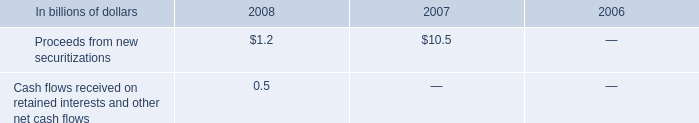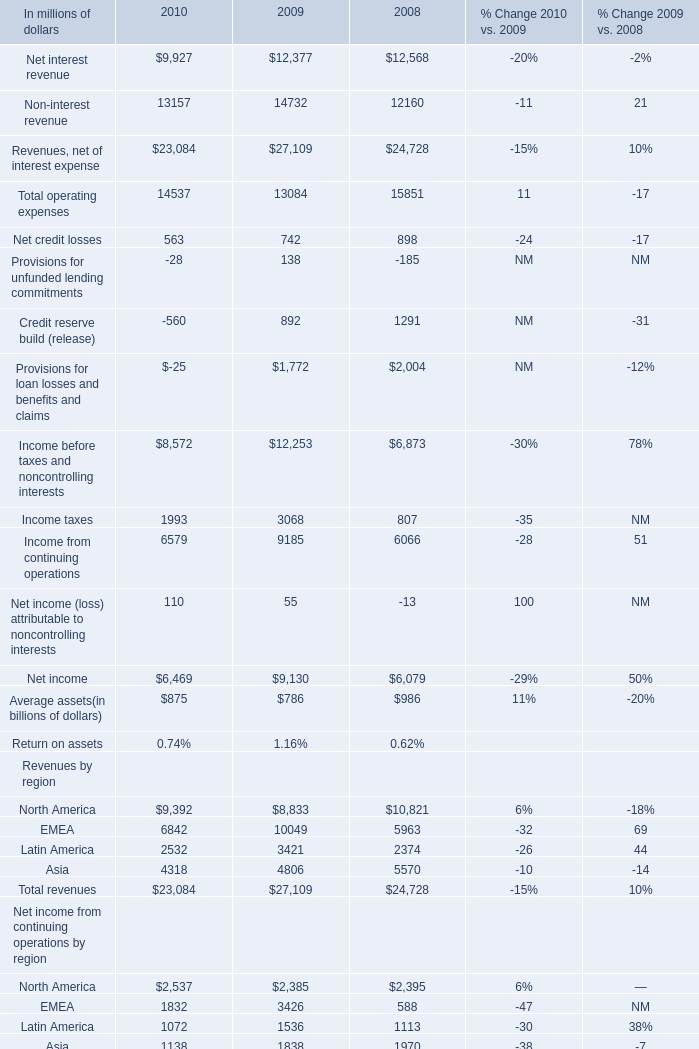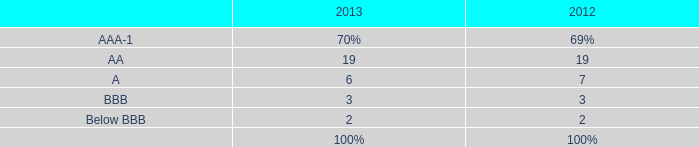If Net interest revenue develops with the same increasing rate in 2009, what will it reach in 2010? (in million) 
Computations: (12377 + ((12377 * (12377 - 12568)) / 12568))
Answer: 12188.90269. 